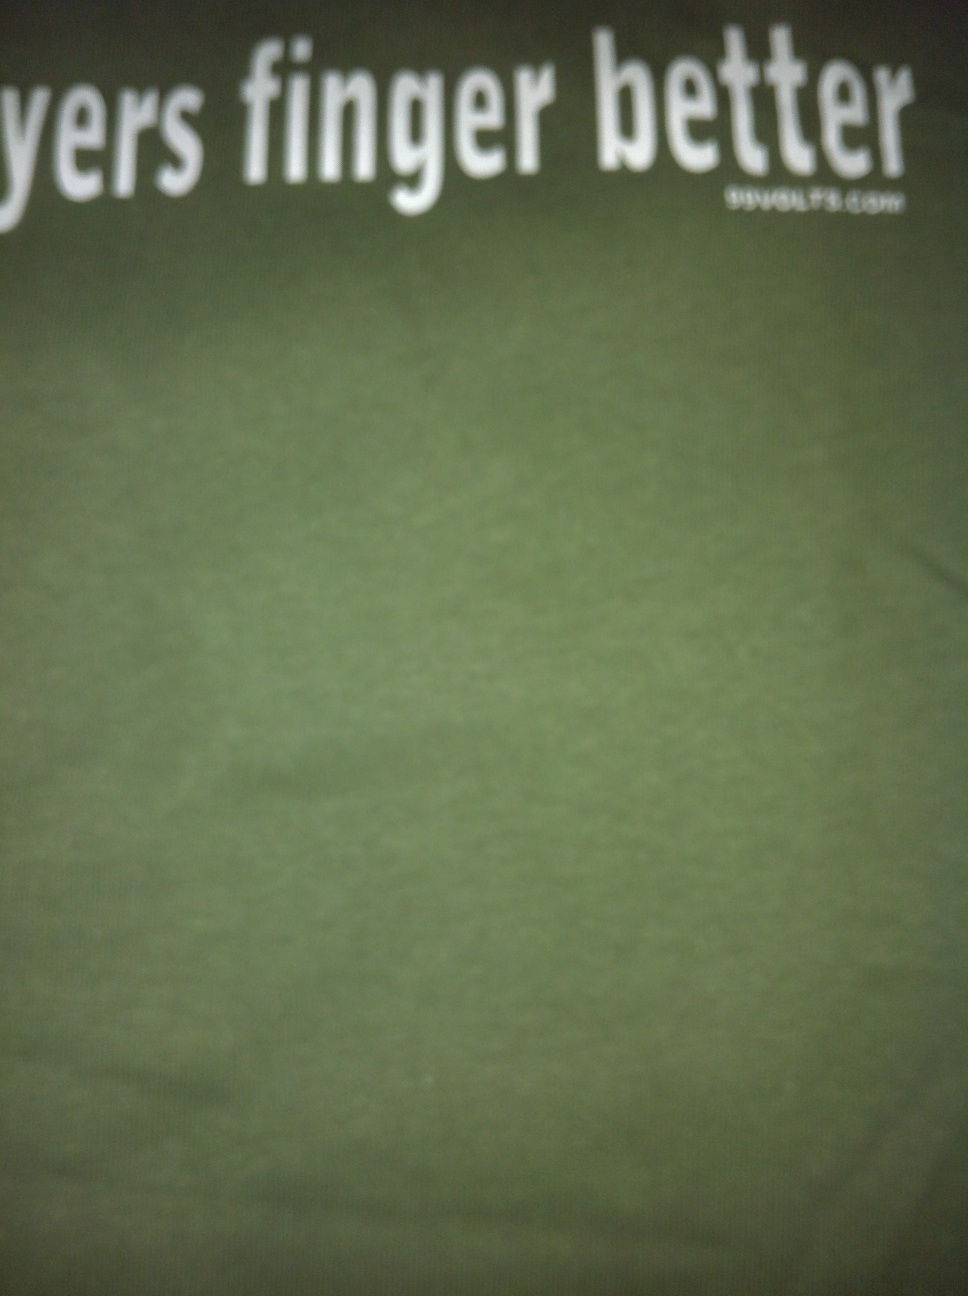Why might someone choose to wear a shirt with such a phrase on it? A t-shirt with a phrase like 'players finger better' is likely chosen for its humorous and provocative appeal. It might be worn by individuals who wish to showcase their playful or irreverent side, particularly among peers who appreciate musical or gaming puns. It can be a conversation starter or a way to express personal style and humor. 